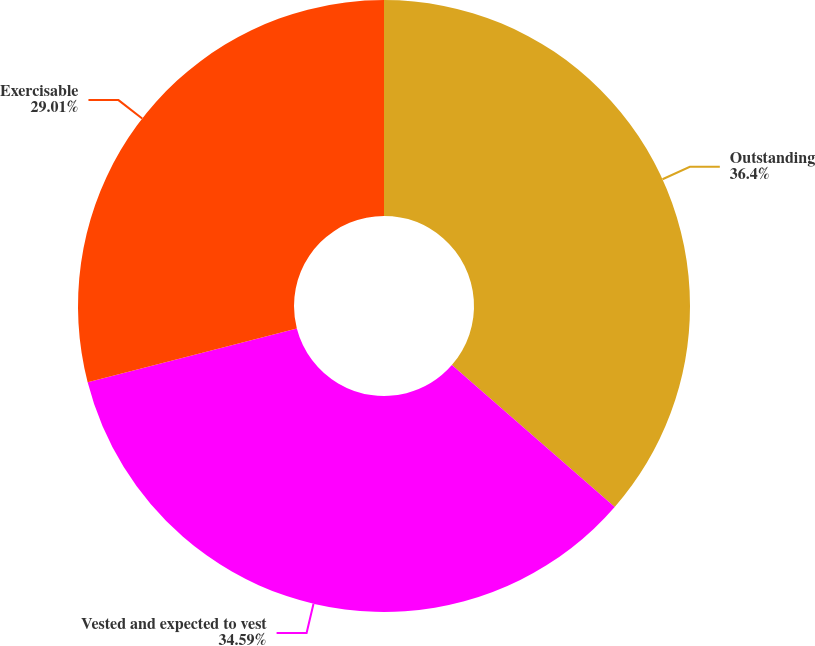<chart> <loc_0><loc_0><loc_500><loc_500><pie_chart><fcel>Outstanding<fcel>Vested and expected to vest<fcel>Exercisable<nl><fcel>36.41%<fcel>34.59%<fcel>29.01%<nl></chart> 